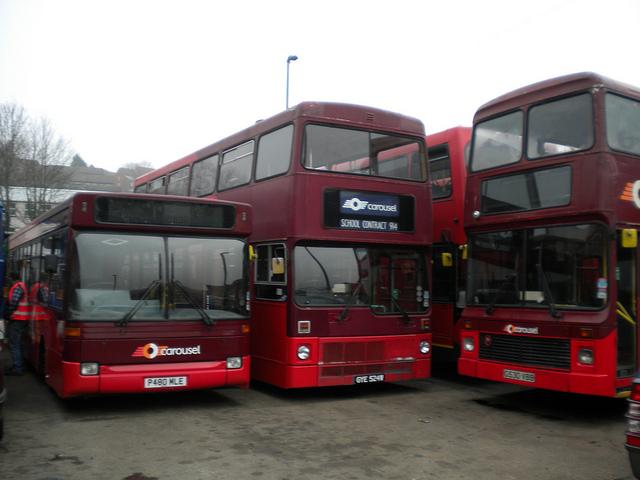Are all these the same model?
Quick response, please. No. Why are there two levels on the bus?
Short answer required. To hold more people. How many versions of buses are in this picture?
Be succinct. 2. 